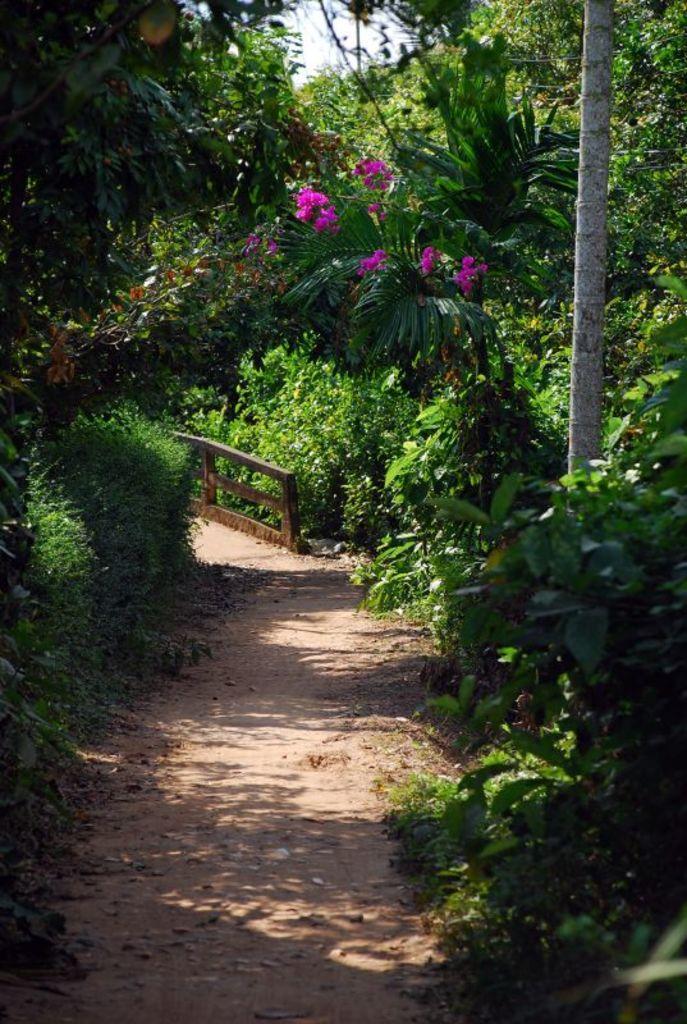Can you describe this image briefly? In the center of the image there is a road. On both left side and right side of the image there are plants, trees. There is a wooden fence. In the background of the image there is sky. 